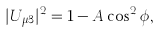<formula> <loc_0><loc_0><loc_500><loc_500>| U _ { \mu 3 } | ^ { 2 } = 1 - A \cos ^ { 2 } \phi ,</formula> 